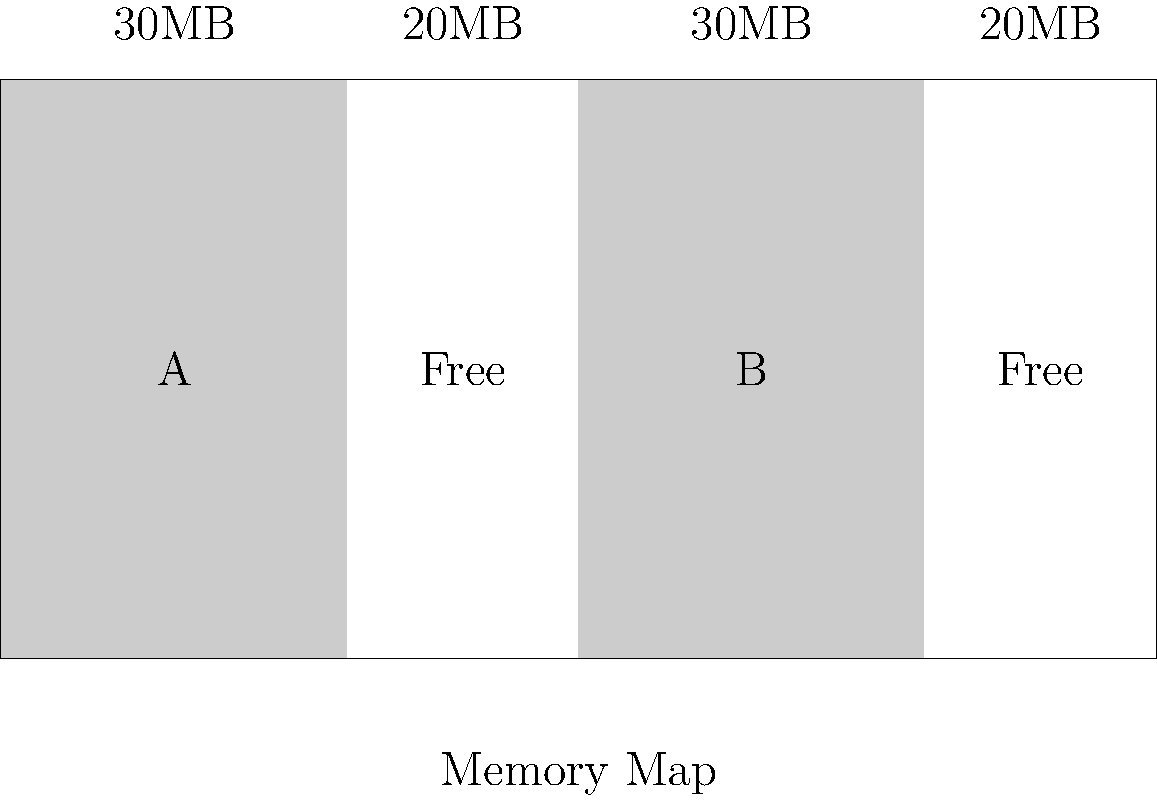In the given memory map, which represents a system with 100MB of total memory, what is the largest contiguous block of free memory available? How would this affect the allocation of a new process requiring 25MB of memory? To answer this question, we need to analyze the memory map step-by-step:

1. The total memory is 100MB, represented by the entire rectangle.

2. There are four blocks in the memory map:
   - Block A: 30MB (allocated)
   - Free block: 20MB
   - Block B: 30MB (allocated)
   - Free block: 20MB

3. The two free blocks are not contiguous, as they are separated by an allocated block (B).

4. The largest contiguous block of free memory is 20MB, which is the size of each free block.

5. If a new process requires 25MB of memory:
   - It cannot be allocated in a single contiguous block, as the largest free block is only 20MB.
   - This situation is an example of memory fragmentation, where the total free memory (40MB) is sufficient, but it's not in a contiguous block.

6. In Ubuntu or other Linux systems, this would typically trigger the memory manager to use techniques like:
   - Memory compaction: moving allocated blocks to create larger contiguous free spaces.
   - Virtual memory: using swap space on the disk to handle memory that doesn't fit in physical RAM.
   - Or, it might simply fail to allocate the memory if these techniques are not available or sufficient.
Answer: 20MB; cannot be allocated without memory management techniques 